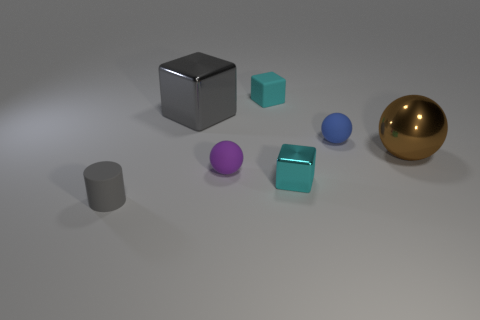How would you describe the overall arrangement of objects in this scene? The scene displays an organized collection of objects with varying shapes, colors, and materials. There is an interesting use of space, with objects placed at intervals giving it a structured yet dynamic appearance. Can you tell me more about the materials the objects might be made of? Certainly, the larger block on the left seems to have a matte, opaque surface possibly resembling plastic or painted metal. The small cube and the cylindrical shape have a similar matte finish. In contrast, the spherical object on the right has a reflective surface, like that of polished metal or glass. The blue object also has a reflective characteristic, though slightly less lustrous. 